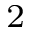<formula> <loc_0><loc_0><loc_500><loc_500>_ { 2 }</formula> 